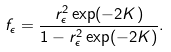Convert formula to latex. <formula><loc_0><loc_0><loc_500><loc_500>f _ { \epsilon } = \frac { r _ { \epsilon } ^ { 2 } \exp ( - 2 K ) } { 1 - r _ { \epsilon } ^ { 2 } \exp ( - 2 K ) } .</formula> 